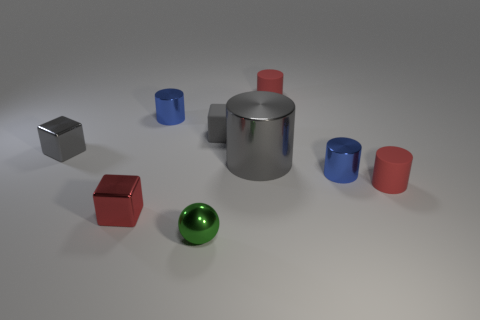Is there anything else that has the same size as the gray cylinder?
Keep it short and to the point. No. There is a gray cylinder that is made of the same material as the small green sphere; what size is it?
Provide a succinct answer. Large. What number of things are small metal objects left of the rubber cube or large blue cylinders?
Provide a succinct answer. 4. There is a rubber object on the left side of the large gray shiny cylinder; does it have the same color as the large metallic cylinder?
Your response must be concise. Yes. There is another gray object that is the same shape as the tiny gray rubber thing; what is its size?
Offer a very short reply. Small. The big shiny cylinder that is to the left of the small red cylinder that is behind the blue metallic thing right of the green shiny object is what color?
Offer a very short reply. Gray. There is a tiny matte cylinder that is to the right of the red object behind the gray matte thing; is there a small gray metal block that is behind it?
Provide a succinct answer. Yes. Do the sphere and the rubber block have the same color?
Provide a succinct answer. No. Is the number of gray blocks less than the number of red blocks?
Provide a succinct answer. No. Does the large gray object that is right of the small green metal ball have the same material as the small red cylinder behind the large gray thing?
Your response must be concise. No. 